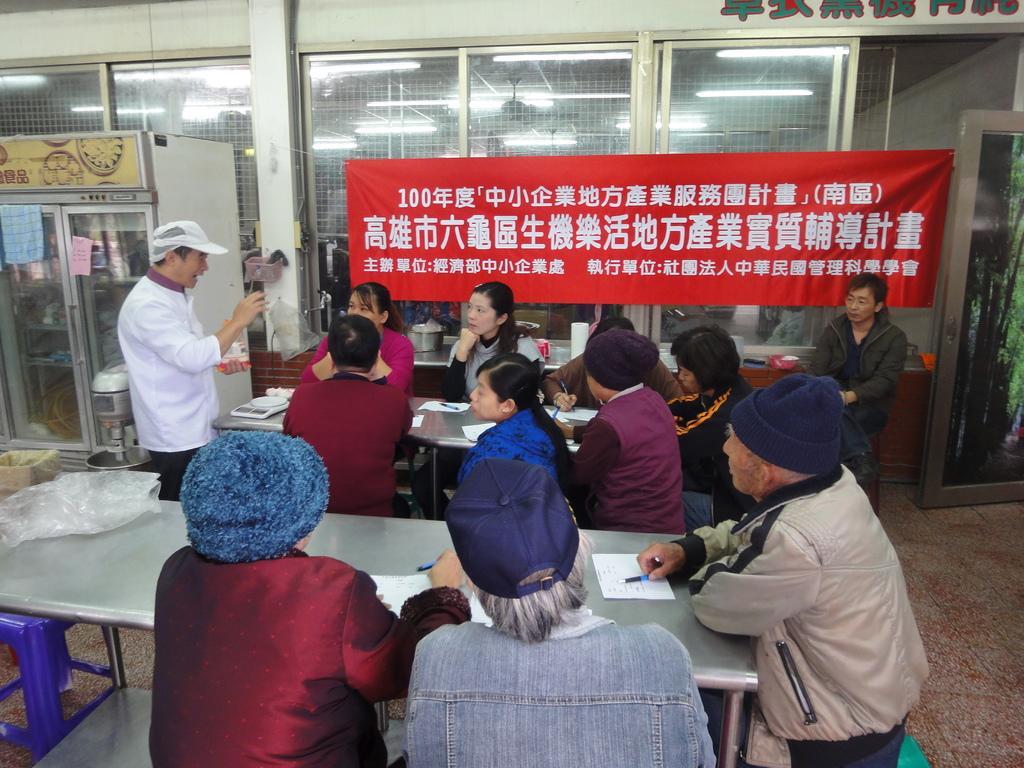Could you give a brief overview of what you see in this image? In the foreground of this image, there are few people sitting near tables on which there are pens and papers and few are holding pens. On the left, there is a man standing, a refrigerator, a cardboard box, an object, a cover on the table and a blue stool. In the background, there is a banner, glass wall and a door on the right. 